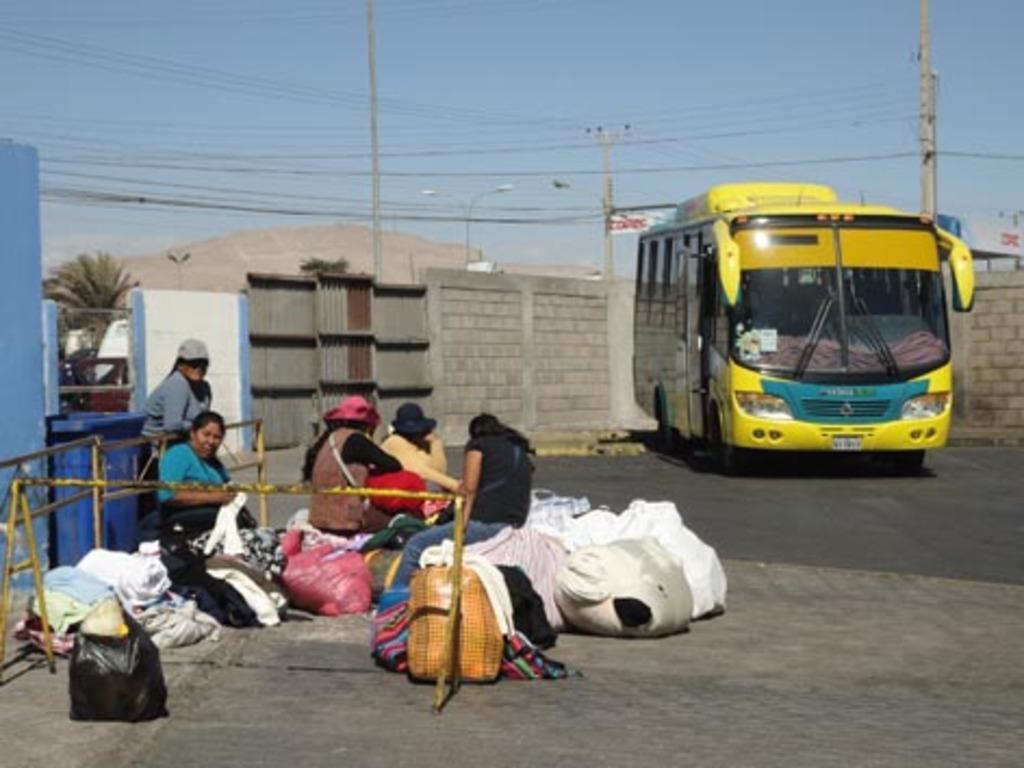Could you give a brief overview of what you see in this image? In this image I can see few people are sitting on the bags and one person is standing. I can see few vehicles, wall, blue basket, trees, current poles, wires, light poles and trees. The sky is in blue color. 